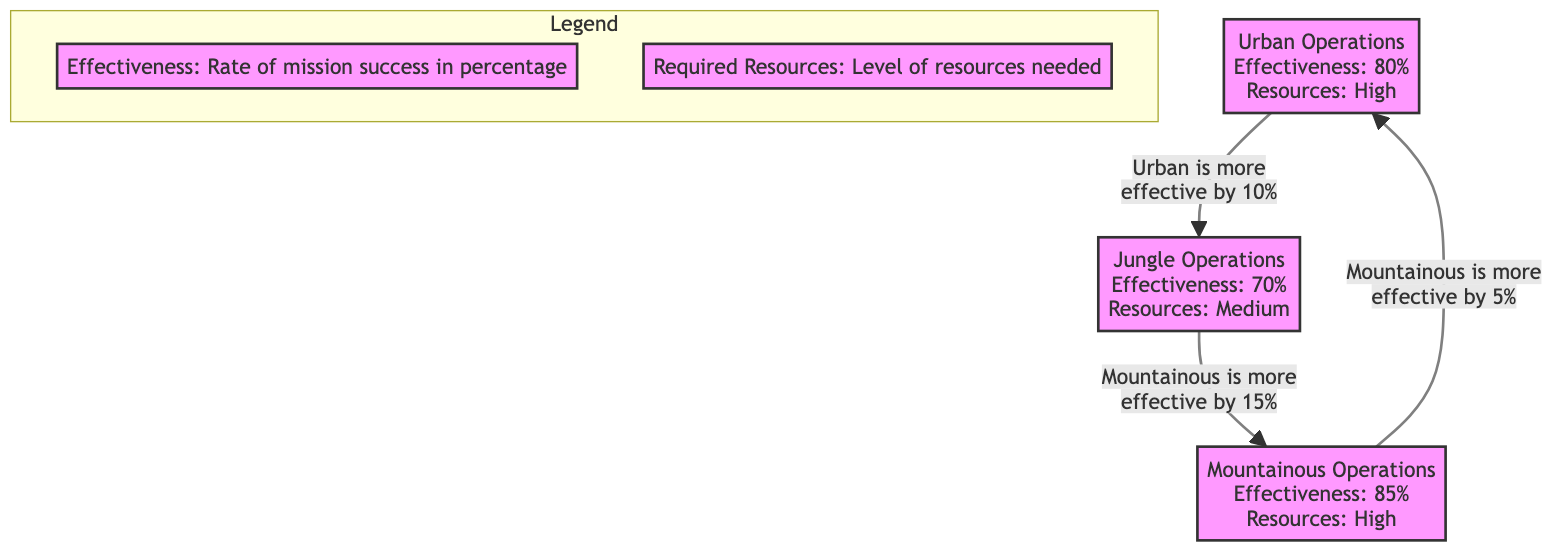What is the effectiveness rate of Urban Operations? The diagram indicates that Urban Operations have an effectiveness rate of 80%, as it is stated under the Urban Operations node.
Answer: 80% How many operations types are compared in the diagram? The diagram displays three types of operations: Urban, Jungle, and Mountainous. Therefore, there are a total of three operations types compared.
Answer: 3 Which operation requires high resources? Both Urban and Mountainous Operations require high resources, as indicated in their respective nodes.
Answer: Urban and Mountainous What is the effectiveness rate of Jungle Operations? The node for Jungle Operations specifies that the effectiveness rate is 70%.
Answer: 70% Which operation is more effective than Jungle Operations? The diagram shows that Urban Operations are more effective than Jungle Operations by 10%, thus indicating that Urban Operations are the comparison reference.
Answer: Urban Operations What is the difference in effectiveness between Mountainous and Urban Operations? The diagram states that Mountainous Operations are 5% more effective than Urban Operations, as indicated in the relationship arrow.
Answer: 5% Which operation has the highest effectiveness rate? According to the comparison, Mountainous Operations have the highest effectiveness rate at 85%.
Answer: Mountainous Operations How many edges are present in the diagram? There are three directed edges in the diagram, showing the relationships (comparisons) among the three operation types.
Answer: 3 What type of terrain has a medium resource requirement? The Jungle Operations node highlights that these operations have a medium resource requirement.
Answer: Jungle Operations 